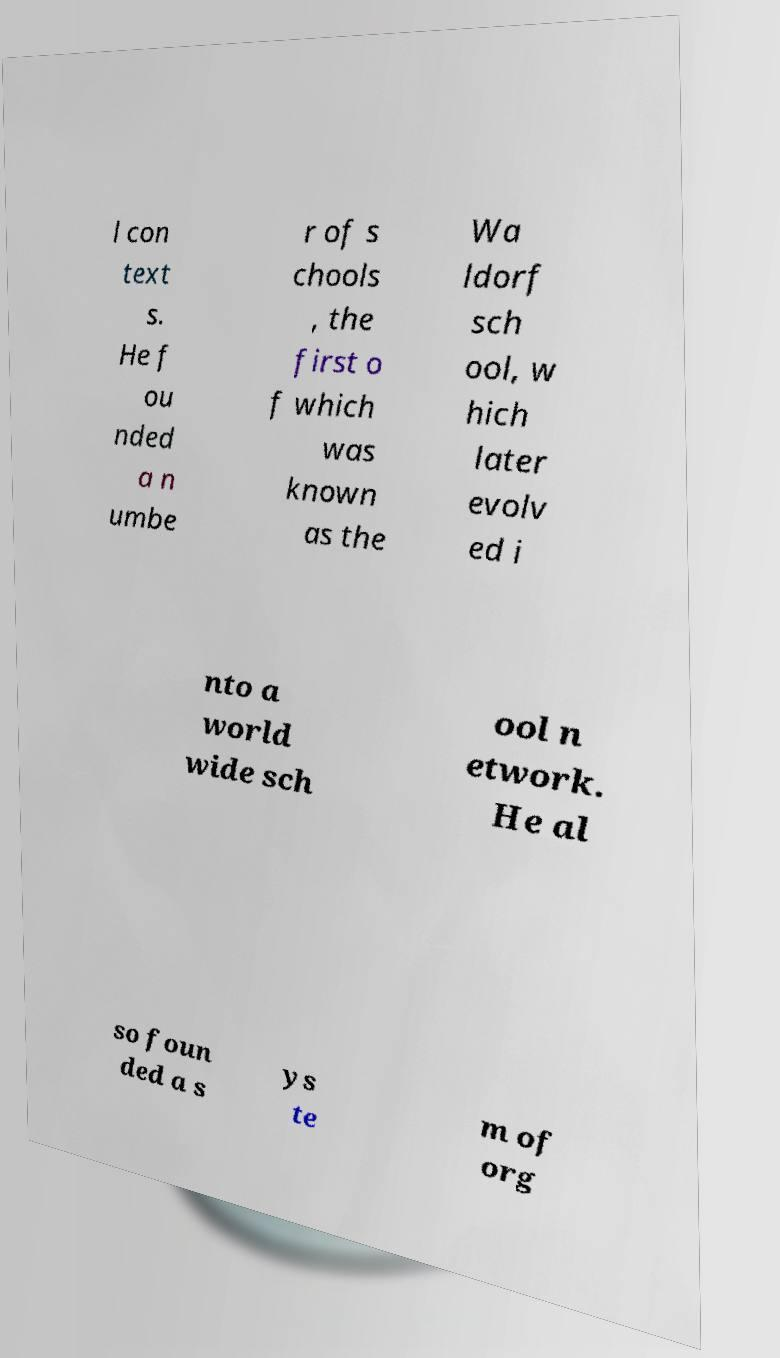Please read and relay the text visible in this image. What does it say? l con text s. He f ou nded a n umbe r of s chools , the first o f which was known as the Wa ldorf sch ool, w hich later evolv ed i nto a world wide sch ool n etwork. He al so foun ded a s ys te m of org 